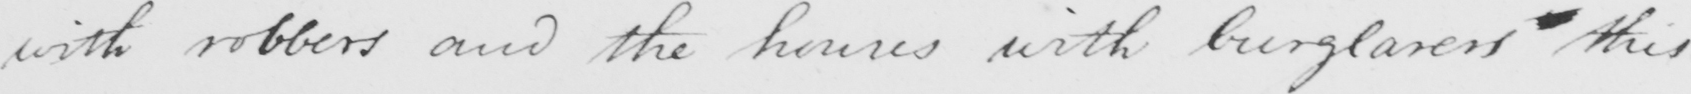Please transcribe the handwritten text in this image. with robbers and the houses with burglarers this 